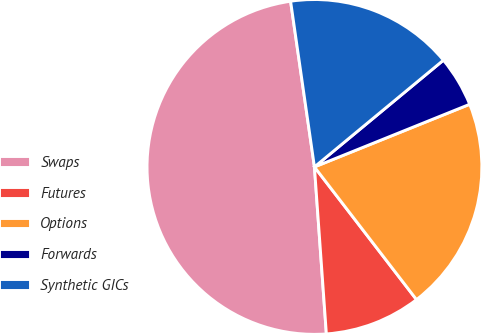<chart> <loc_0><loc_0><loc_500><loc_500><pie_chart><fcel>Swaps<fcel>Futures<fcel>Options<fcel>Forwards<fcel>Synthetic GICs<nl><fcel>48.86%<fcel>9.3%<fcel>20.67%<fcel>4.9%<fcel>16.27%<nl></chart> 